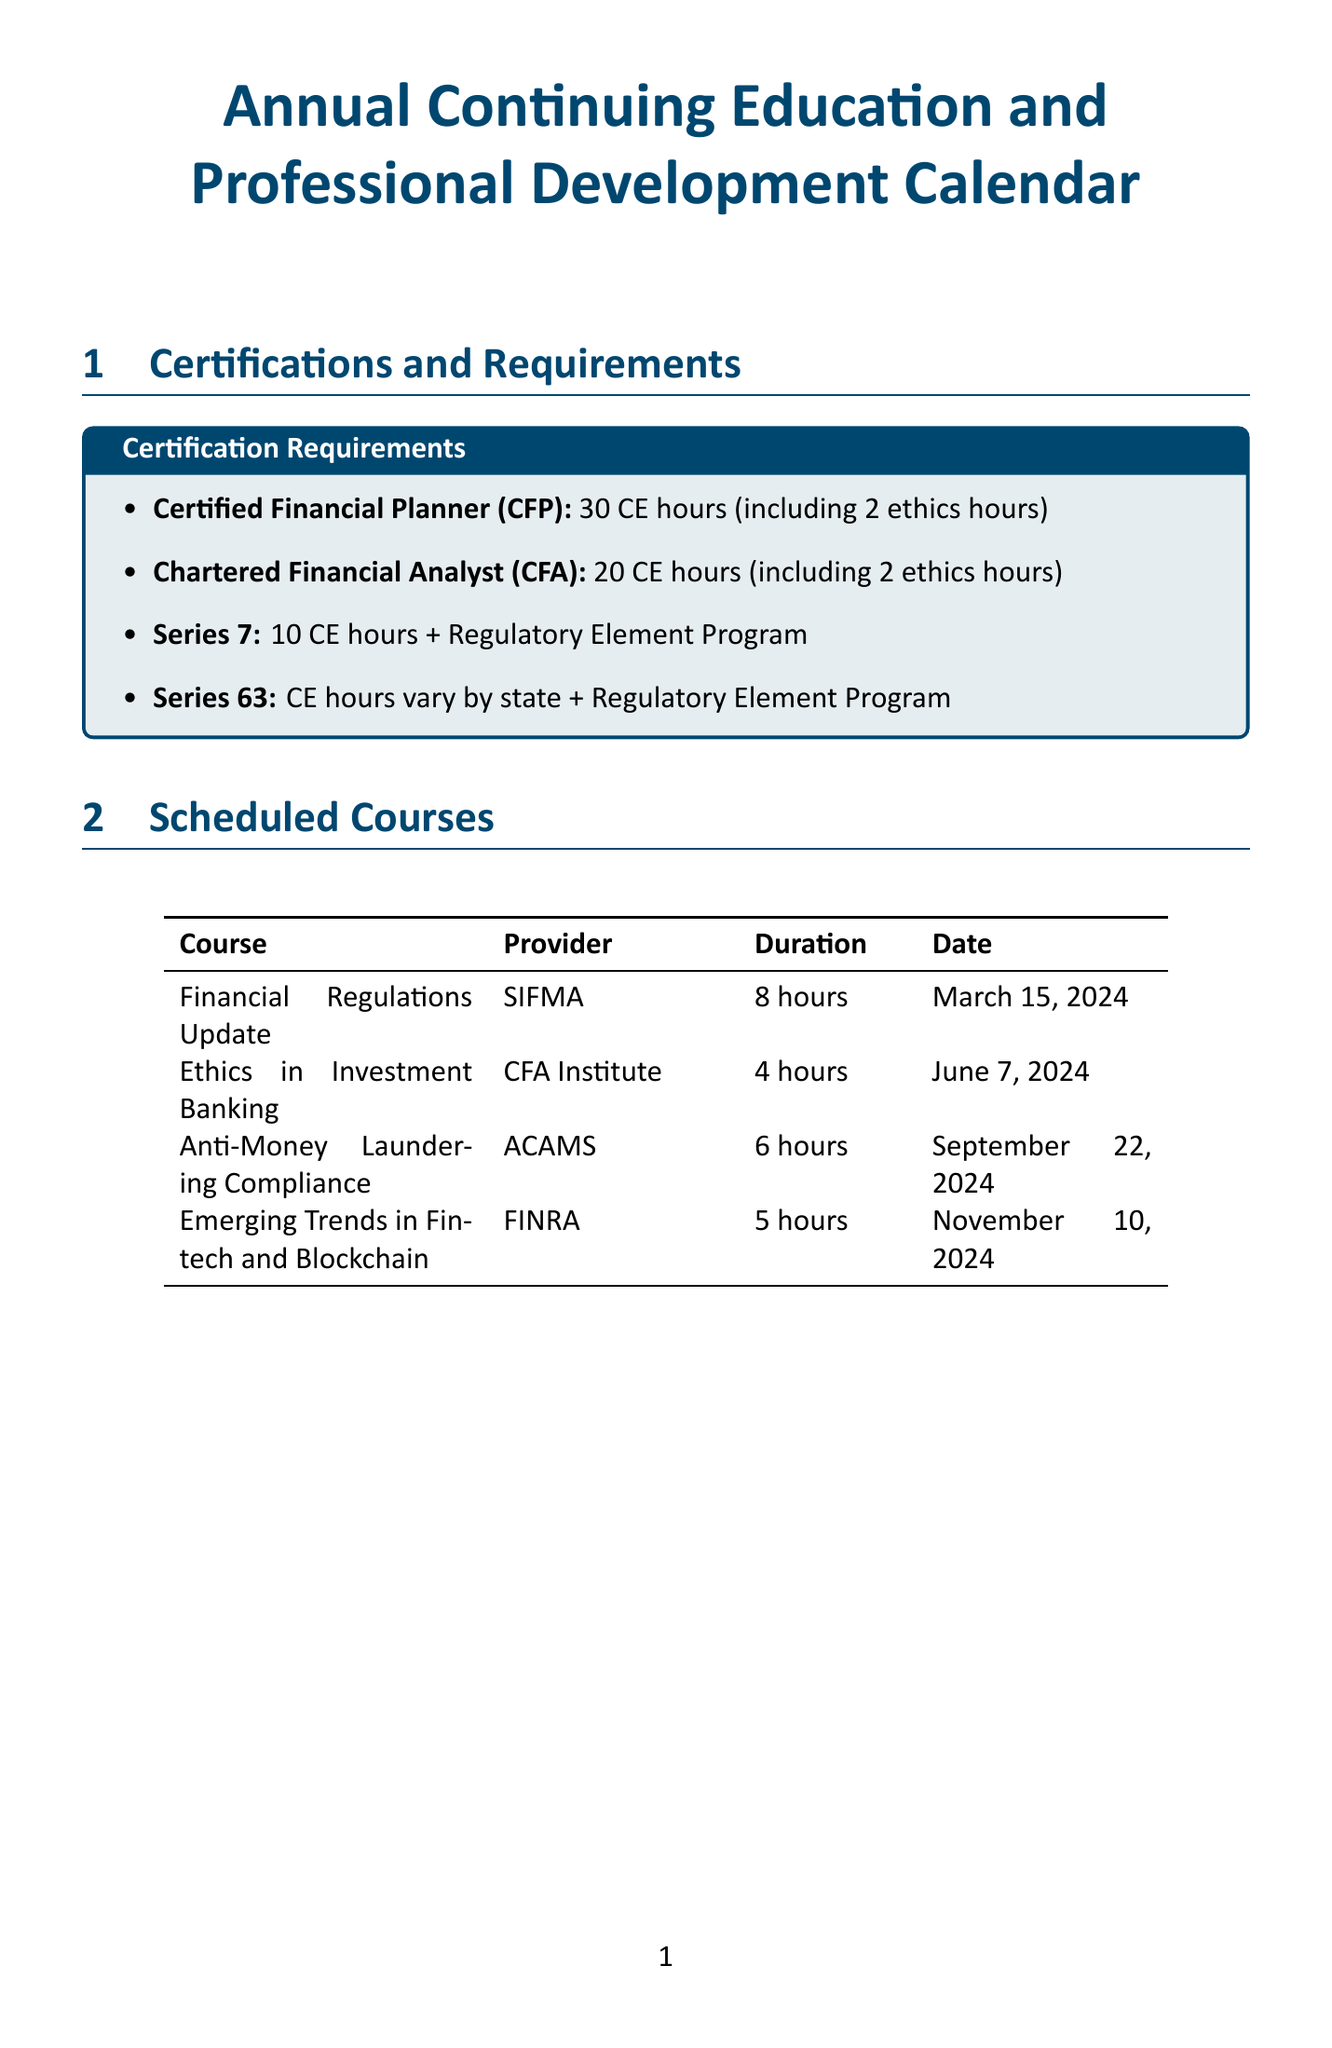what are the CE hours required for CFP certification? The document states that Certified Financial Planner (CFP) certification requires 30 CE hours, including 2 ethics hours.
Answer: 30 CE hours what is the date of the Ethics in Investment Banking course? The course titled "Ethics in Investment Banking" is scheduled for June 7, 2024, as indicated in the document.
Answer: June 7, 2024 how many CE hours does the Global Financial Services Compliance Symposium provide? According to the document, the Global Financial Services Compliance Symposium offers 16 CE hours.
Answer: 16 CE hours what is the format of the Anti-Money Laundering Compliance course? The document specifies that the Anti-Money Laundering Compliance course is a virtual conference.
Answer: Virtual conference how often is the Regulatory Compliance Update training held? The document outlines that the Regulatory Compliance Update training is held quarterly.
Answer: Quarterly what is the annual fee for the American Bankers Association membership? The annual fee for the American Bankers Association (ABA) membership, as per the document, is $395.
Answer: $395 what total CE hours are required for the Series 7 certification? The Series 7 certification requires 10 CE hours plus completion of the Regulatory Element Program.
Answer: 10 CE hours what is the duration of the Emerging Trends in Fintech and Blockchain course? The duration of the Emerging Trends in Fintech and Blockchain course is listed as 5 hours in the document.
Answer: 5 hours where is the Investment Banking Technology Summit taking place? The document indicates that the Investment Banking Technology Summit will be held in New York City, USA.
Answer: New York City, USA 